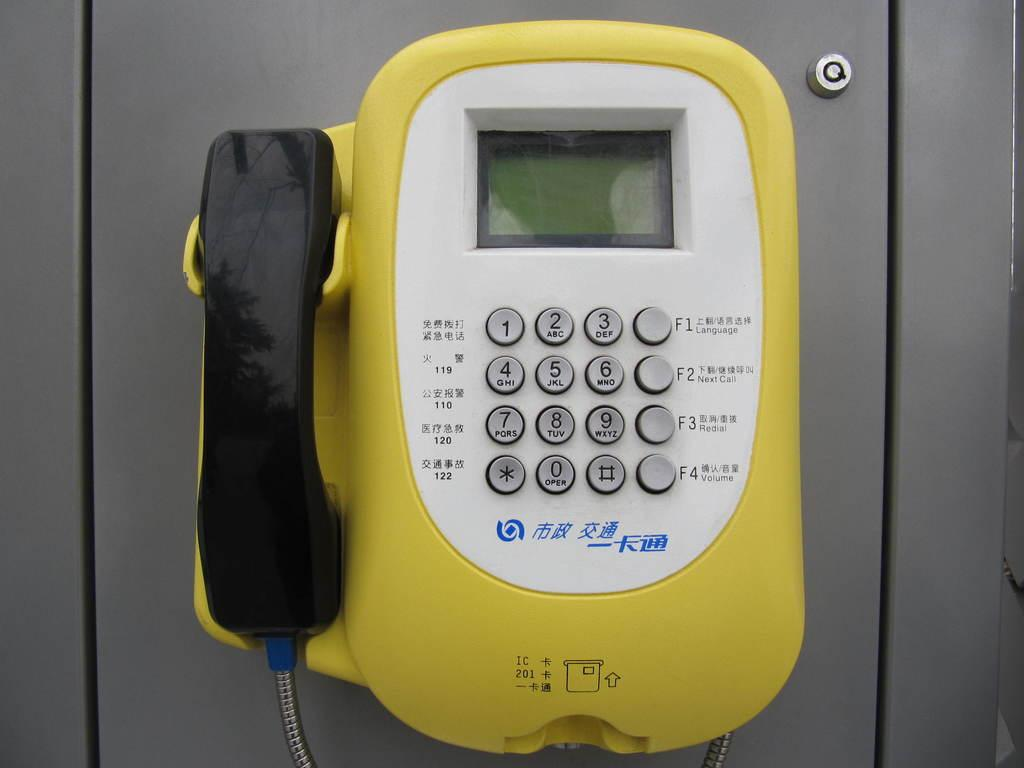What type of communication device is in the image? There is a telephone in the image. What feature does the telephone have for displaying information? The telephone has a digital display. How can a user input numbers or commands on the telephone? The telephone has a keypad for inputting numbers or commands. Where is the handset located on the telephone? The handset is on the left side of the telephone. What type of zipper can be seen on the secretary's dress in the image? There is no secretary or dress present in the image; it only features a telephone. How does the balance of the telephone affect its functionality in the image? The balance of the telephone is not mentioned in the provided facts, and therefore its effect on functionality cannot be determined. 